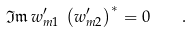Convert formula to latex. <formula><loc_0><loc_0><loc_500><loc_500>\mathfrak { I m } \, w ^ { \prime } _ { m 1 } \, \left ( w ^ { \prime } _ { m 2 } \right ) ^ { * } = 0 \quad .</formula> 